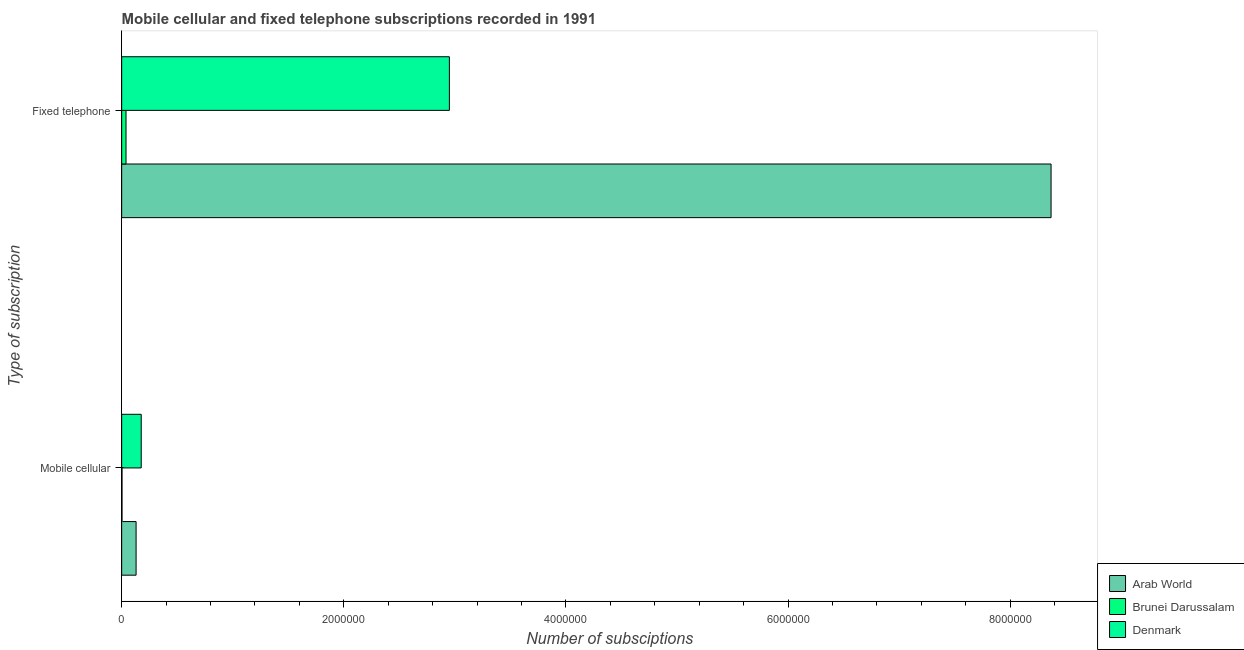How many different coloured bars are there?
Offer a very short reply. 3. How many groups of bars are there?
Provide a succinct answer. 2. Are the number of bars per tick equal to the number of legend labels?
Ensure brevity in your answer.  Yes. How many bars are there on the 2nd tick from the top?
Provide a short and direct response. 3. How many bars are there on the 1st tick from the bottom?
Your answer should be very brief. 3. What is the label of the 2nd group of bars from the top?
Keep it short and to the point. Mobile cellular. What is the number of mobile cellular subscriptions in Denmark?
Provide a succinct answer. 1.76e+05. Across all countries, what is the maximum number of fixed telephone subscriptions?
Provide a succinct answer. 8.37e+06. Across all countries, what is the minimum number of fixed telephone subscriptions?
Keep it short and to the point. 3.91e+04. In which country was the number of fixed telephone subscriptions minimum?
Provide a short and direct response. Brunei Darussalam. What is the total number of fixed telephone subscriptions in the graph?
Ensure brevity in your answer.  1.14e+07. What is the difference between the number of fixed telephone subscriptions in Arab World and that in Denmark?
Provide a succinct answer. 5.42e+06. What is the difference between the number of fixed telephone subscriptions in Brunei Darussalam and the number of mobile cellular subscriptions in Arab World?
Offer a terse response. -9.08e+04. What is the average number of mobile cellular subscriptions per country?
Make the answer very short. 1.03e+05. What is the difference between the number of fixed telephone subscriptions and number of mobile cellular subscriptions in Brunei Darussalam?
Keep it short and to the point. 3.61e+04. In how many countries, is the number of fixed telephone subscriptions greater than 6800000 ?
Provide a succinct answer. 1. What is the ratio of the number of fixed telephone subscriptions in Arab World to that in Brunei Darussalam?
Offer a terse response. 214.08. In how many countries, is the number of mobile cellular subscriptions greater than the average number of mobile cellular subscriptions taken over all countries?
Ensure brevity in your answer.  2. What does the 3rd bar from the top in Mobile cellular represents?
Give a very brief answer. Arab World. Are all the bars in the graph horizontal?
Provide a succinct answer. Yes. Are the values on the major ticks of X-axis written in scientific E-notation?
Your response must be concise. No. Does the graph contain any zero values?
Your response must be concise. No. Where does the legend appear in the graph?
Keep it short and to the point. Bottom right. How many legend labels are there?
Give a very brief answer. 3. What is the title of the graph?
Ensure brevity in your answer.  Mobile cellular and fixed telephone subscriptions recorded in 1991. Does "St. Vincent and the Grenadines" appear as one of the legend labels in the graph?
Make the answer very short. No. What is the label or title of the X-axis?
Your response must be concise. Number of subsciptions. What is the label or title of the Y-axis?
Your answer should be very brief. Type of subscription. What is the Number of subsciptions in Arab World in Mobile cellular?
Your response must be concise. 1.30e+05. What is the Number of subsciptions in Brunei Darussalam in Mobile cellular?
Offer a terse response. 3025. What is the Number of subsciptions of Denmark in Mobile cellular?
Your answer should be compact. 1.76e+05. What is the Number of subsciptions in Arab World in Fixed telephone?
Provide a short and direct response. 8.37e+06. What is the Number of subsciptions of Brunei Darussalam in Fixed telephone?
Your answer should be very brief. 3.91e+04. What is the Number of subsciptions in Denmark in Fixed telephone?
Make the answer very short. 2.95e+06. Across all Type of subscription, what is the maximum Number of subsciptions in Arab World?
Provide a succinct answer. 8.37e+06. Across all Type of subscription, what is the maximum Number of subsciptions in Brunei Darussalam?
Give a very brief answer. 3.91e+04. Across all Type of subscription, what is the maximum Number of subsciptions of Denmark?
Provide a short and direct response. 2.95e+06. Across all Type of subscription, what is the minimum Number of subsciptions of Arab World?
Your answer should be compact. 1.30e+05. Across all Type of subscription, what is the minimum Number of subsciptions in Brunei Darussalam?
Offer a very short reply. 3025. Across all Type of subscription, what is the minimum Number of subsciptions in Denmark?
Ensure brevity in your answer.  1.76e+05. What is the total Number of subsciptions in Arab World in the graph?
Keep it short and to the point. 8.50e+06. What is the total Number of subsciptions of Brunei Darussalam in the graph?
Provide a short and direct response. 4.21e+04. What is the total Number of subsciptions in Denmark in the graph?
Provide a succinct answer. 3.13e+06. What is the difference between the Number of subsciptions in Arab World in Mobile cellular and that in Fixed telephone?
Give a very brief answer. -8.24e+06. What is the difference between the Number of subsciptions in Brunei Darussalam in Mobile cellular and that in Fixed telephone?
Provide a succinct answer. -3.61e+04. What is the difference between the Number of subsciptions in Denmark in Mobile cellular and that in Fixed telephone?
Your answer should be compact. -2.77e+06. What is the difference between the Number of subsciptions in Arab World in Mobile cellular and the Number of subsciptions in Brunei Darussalam in Fixed telephone?
Give a very brief answer. 9.08e+04. What is the difference between the Number of subsciptions of Arab World in Mobile cellular and the Number of subsciptions of Denmark in Fixed telephone?
Provide a succinct answer. -2.82e+06. What is the difference between the Number of subsciptions of Brunei Darussalam in Mobile cellular and the Number of subsciptions of Denmark in Fixed telephone?
Offer a very short reply. -2.95e+06. What is the average Number of subsciptions of Arab World per Type of subscription?
Your answer should be very brief. 4.25e+06. What is the average Number of subsciptions of Brunei Darussalam per Type of subscription?
Offer a terse response. 2.11e+04. What is the average Number of subsciptions in Denmark per Type of subscription?
Your answer should be very brief. 1.56e+06. What is the difference between the Number of subsciptions of Arab World and Number of subsciptions of Brunei Darussalam in Mobile cellular?
Ensure brevity in your answer.  1.27e+05. What is the difference between the Number of subsciptions in Arab World and Number of subsciptions in Denmark in Mobile cellular?
Provide a short and direct response. -4.60e+04. What is the difference between the Number of subsciptions in Brunei Darussalam and Number of subsciptions in Denmark in Mobile cellular?
Ensure brevity in your answer.  -1.73e+05. What is the difference between the Number of subsciptions in Arab World and Number of subsciptions in Brunei Darussalam in Fixed telephone?
Your response must be concise. 8.33e+06. What is the difference between the Number of subsciptions of Arab World and Number of subsciptions of Denmark in Fixed telephone?
Make the answer very short. 5.42e+06. What is the difference between the Number of subsciptions of Brunei Darussalam and Number of subsciptions of Denmark in Fixed telephone?
Give a very brief answer. -2.91e+06. What is the ratio of the Number of subsciptions in Arab World in Mobile cellular to that in Fixed telephone?
Your answer should be compact. 0.02. What is the ratio of the Number of subsciptions of Brunei Darussalam in Mobile cellular to that in Fixed telephone?
Offer a very short reply. 0.08. What is the ratio of the Number of subsciptions of Denmark in Mobile cellular to that in Fixed telephone?
Your response must be concise. 0.06. What is the difference between the highest and the second highest Number of subsciptions of Arab World?
Give a very brief answer. 8.24e+06. What is the difference between the highest and the second highest Number of subsciptions of Brunei Darussalam?
Your answer should be very brief. 3.61e+04. What is the difference between the highest and the second highest Number of subsciptions in Denmark?
Offer a very short reply. 2.77e+06. What is the difference between the highest and the lowest Number of subsciptions in Arab World?
Ensure brevity in your answer.  8.24e+06. What is the difference between the highest and the lowest Number of subsciptions of Brunei Darussalam?
Keep it short and to the point. 3.61e+04. What is the difference between the highest and the lowest Number of subsciptions of Denmark?
Offer a terse response. 2.77e+06. 